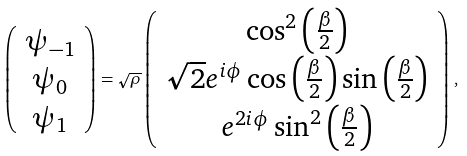Convert formula to latex. <formula><loc_0><loc_0><loc_500><loc_500>\left ( \begin{array} { c } \psi _ { - 1 } \\ \psi _ { 0 } \\ \psi _ { 1 } \end{array} \right ) = \sqrt { \rho } \left ( \begin{array} { c } \cos ^ { 2 } \left ( \frac { \beta } { 2 } \right ) \\ \sqrt { 2 } e ^ { i \phi } \cos \left ( \frac { \beta } { 2 } \right ) \sin \left ( \frac { \beta } { 2 } \right ) \\ e ^ { 2 i \phi } \sin ^ { 2 } \left ( \frac { \beta } { 2 } \right ) \end{array} \right ) \, ,</formula> 